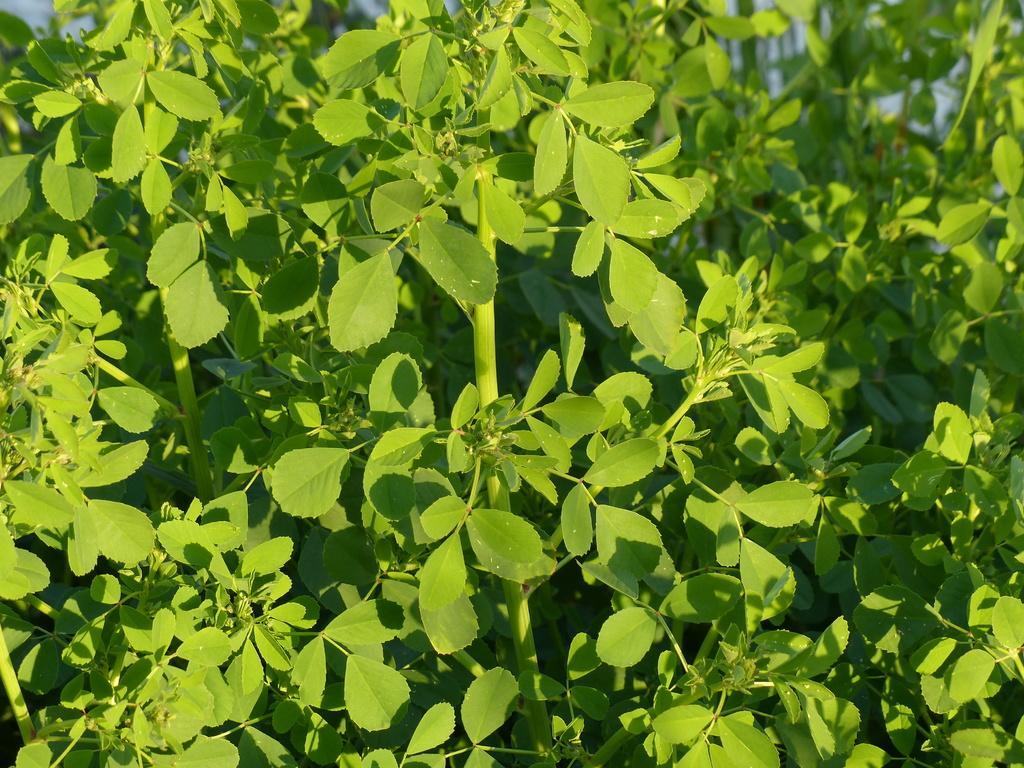Could you give a brief overview of what you see in this image? In this image we can see green leaves and stems. 